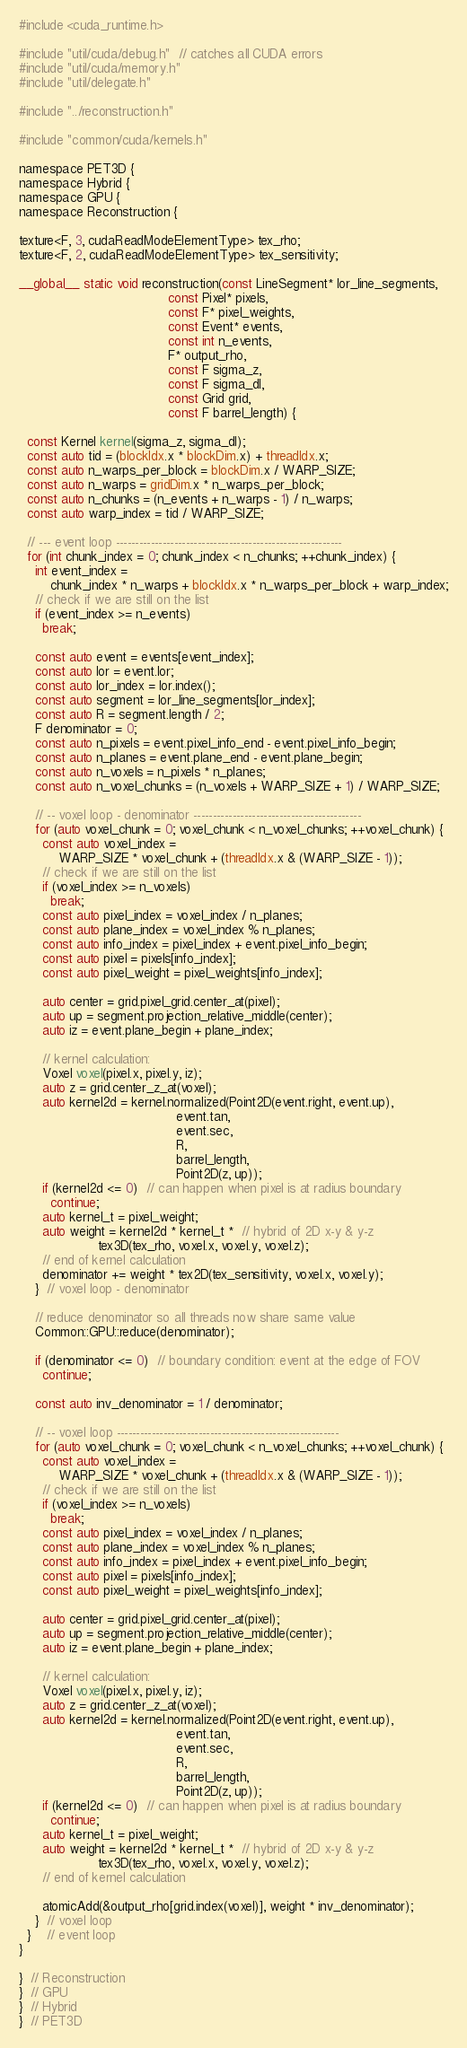<code> <loc_0><loc_0><loc_500><loc_500><_Cuda_>#include <cuda_runtime.h>

#include "util/cuda/debug.h"  // catches all CUDA errors
#include "util/cuda/memory.h"
#include "util/delegate.h"

#include "../reconstruction.h"

#include "common/cuda/kernels.h"

namespace PET3D {
namespace Hybrid {
namespace GPU {
namespace Reconstruction {

texture<F, 3, cudaReadModeElementType> tex_rho;
texture<F, 2, cudaReadModeElementType> tex_sensitivity;

__global__ static void reconstruction(const LineSegment* lor_line_segments,
                                      const Pixel* pixels,
                                      const F* pixel_weights,
                                      const Event* events,
                                      const int n_events,
                                      F* output_rho,
                                      const F sigma_z,
                                      const F sigma_dl,
                                      const Grid grid,
                                      const F barrel_length) {

  const Kernel kernel(sigma_z, sigma_dl);
  const auto tid = (blockIdx.x * blockDim.x) + threadIdx.x;
  const auto n_warps_per_block = blockDim.x / WARP_SIZE;
  const auto n_warps = gridDim.x * n_warps_per_block;
  const auto n_chunks = (n_events + n_warps - 1) / n_warps;
  const auto warp_index = tid / WARP_SIZE;

  // --- event loop ----------------------------------------------------------
  for (int chunk_index = 0; chunk_index < n_chunks; ++chunk_index) {
    int event_index =
        chunk_index * n_warps + blockIdx.x * n_warps_per_block + warp_index;
    // check if we are still on the list
    if (event_index >= n_events)
      break;

    const auto event = events[event_index];
    const auto lor = event.lor;
    const auto lor_index = lor.index();
    const auto segment = lor_line_segments[lor_index];
    const auto R = segment.length / 2;
    F denominator = 0;
    const auto n_pixels = event.pixel_info_end - event.pixel_info_begin;
    const auto n_planes = event.plane_end - event.plane_begin;
    const auto n_voxels = n_pixels * n_planes;
    const auto n_voxel_chunks = (n_voxels + WARP_SIZE + 1) / WARP_SIZE;

    // -- voxel loop - denominator -------------------------------------------
    for (auto voxel_chunk = 0; voxel_chunk < n_voxel_chunks; ++voxel_chunk) {
      const auto voxel_index =
          WARP_SIZE * voxel_chunk + (threadIdx.x & (WARP_SIZE - 1));
      // check if we are still on the list
      if (voxel_index >= n_voxels)
        break;
      const auto pixel_index = voxel_index / n_planes;
      const auto plane_index = voxel_index % n_planes;
      const auto info_index = pixel_index + event.pixel_info_begin;
      const auto pixel = pixels[info_index];
      const auto pixel_weight = pixel_weights[info_index];

      auto center = grid.pixel_grid.center_at(pixel);
      auto up = segment.projection_relative_middle(center);
      auto iz = event.plane_begin + plane_index;

      // kernel calculation:
      Voxel voxel(pixel.x, pixel.y, iz);
      auto z = grid.center_z_at(voxel);
      auto kernel2d = kernel.normalized(Point2D(event.right, event.up),
                                        event.tan,
                                        event.sec,
                                        R,
                                        barrel_length,
                                        Point2D(z, up));
      if (kernel2d <= 0)  // can happen when pixel is at radius boundary
        continue;
      auto kernel_t = pixel_weight;
      auto weight = kernel2d * kernel_t *  // hybrid of 2D x-y & y-z
                    tex3D(tex_rho, voxel.x, voxel.y, voxel.z);
      // end of kernel calculation
      denominator += weight * tex2D(tex_sensitivity, voxel.x, voxel.y);
    }  // voxel loop - denominator

    // reduce denominator so all threads now share same value
    Common::GPU::reduce(denominator);

    if (denominator <= 0)  // boundary condition: event at the edge of FOV
      continue;

    const auto inv_denominator = 1 / denominator;

    // -- voxel loop ---------------------------------------------------------
    for (auto voxel_chunk = 0; voxel_chunk < n_voxel_chunks; ++voxel_chunk) {
      const auto voxel_index =
          WARP_SIZE * voxel_chunk + (threadIdx.x & (WARP_SIZE - 1));
      // check if we are still on the list
      if (voxel_index >= n_voxels)
        break;
      const auto pixel_index = voxel_index / n_planes;
      const auto plane_index = voxel_index % n_planes;
      const auto info_index = pixel_index + event.pixel_info_begin;
      const auto pixel = pixels[info_index];
      const auto pixel_weight = pixel_weights[info_index];

      auto center = grid.pixel_grid.center_at(pixel);
      auto up = segment.projection_relative_middle(center);
      auto iz = event.plane_begin + plane_index;

      // kernel calculation:
      Voxel voxel(pixel.x, pixel.y, iz);
      auto z = grid.center_z_at(voxel);
      auto kernel2d = kernel.normalized(Point2D(event.right, event.up),
                                        event.tan,
                                        event.sec,
                                        R,
                                        barrel_length,
                                        Point2D(z, up));
      if (kernel2d <= 0)  // can happen when pixel is at radius boundary
        continue;
      auto kernel_t = pixel_weight;
      auto weight = kernel2d * kernel_t *  // hybrid of 2D x-y & y-z
                    tex3D(tex_rho, voxel.x, voxel.y, voxel.z);
      // end of kernel calculation

      atomicAdd(&output_rho[grid.index(voxel)], weight * inv_denominator);
    }  // voxel loop
  }    // event loop
}

}  // Reconstruction
}  // GPU
}  // Hybrid
}  // PET3D
</code> 